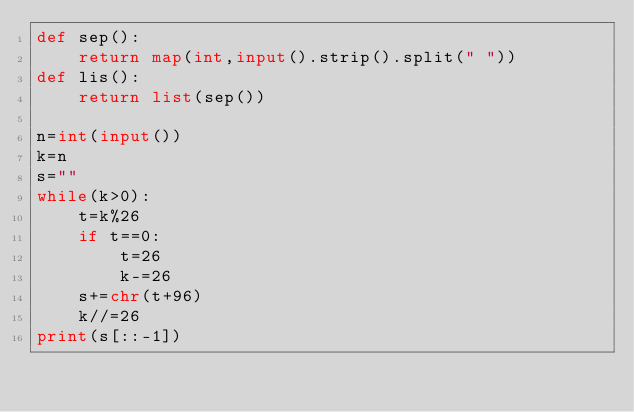<code> <loc_0><loc_0><loc_500><loc_500><_Python_>def sep():
    return map(int,input().strip().split(" "))
def lis():
    return list(sep())

n=int(input())
k=n
s=""
while(k>0):
    t=k%26
    if t==0:
        t=26
        k-=26
    s+=chr(t+96)
    k//=26
print(s[::-1])
</code> 